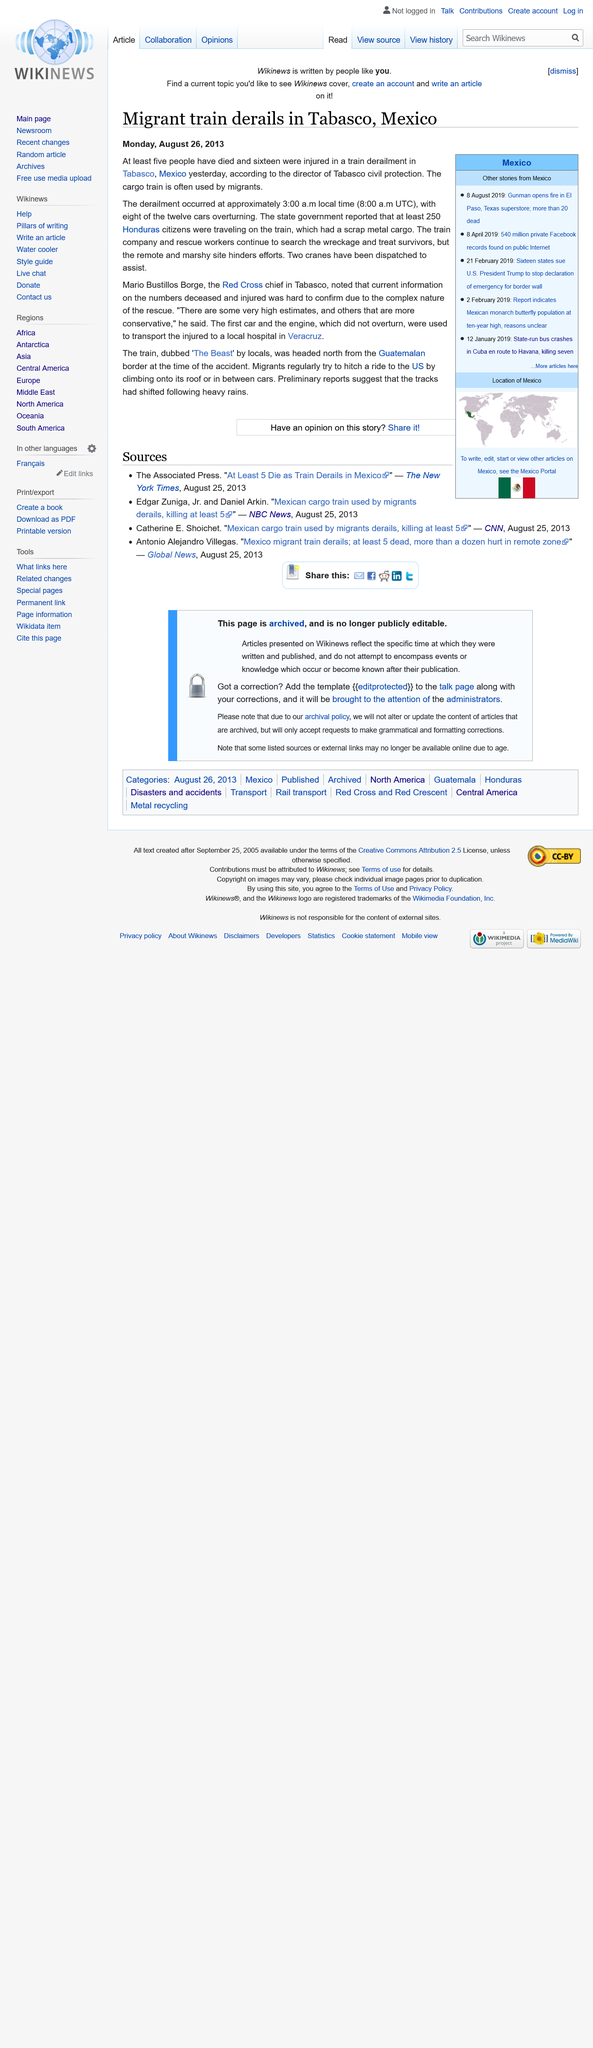List a handful of essential elements in this visual. The injured passengers from the train derailment were transported to a hospital located in the city of Veracruz for medical treatment. On August 25, 2013, a migrant train derailed in Tabasco, Mexico. Eight of the twelve train cars were overturned when the migrant train derailed. 